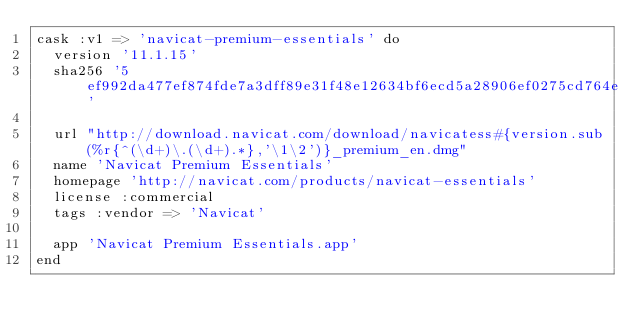Convert code to text. <code><loc_0><loc_0><loc_500><loc_500><_Ruby_>cask :v1 => 'navicat-premium-essentials' do
  version '11.1.15'
  sha256 '5ef992da477ef874fde7a3dff89e31f48e12634bf6ecd5a28906ef0275cd764e'

  url "http://download.navicat.com/download/navicatess#{version.sub(%r{^(\d+)\.(\d+).*},'\1\2')}_premium_en.dmg"
  name 'Navicat Premium Essentials'
  homepage 'http://navicat.com/products/navicat-essentials'
  license :commercial
  tags :vendor => 'Navicat'

  app 'Navicat Premium Essentials.app'
end
</code> 